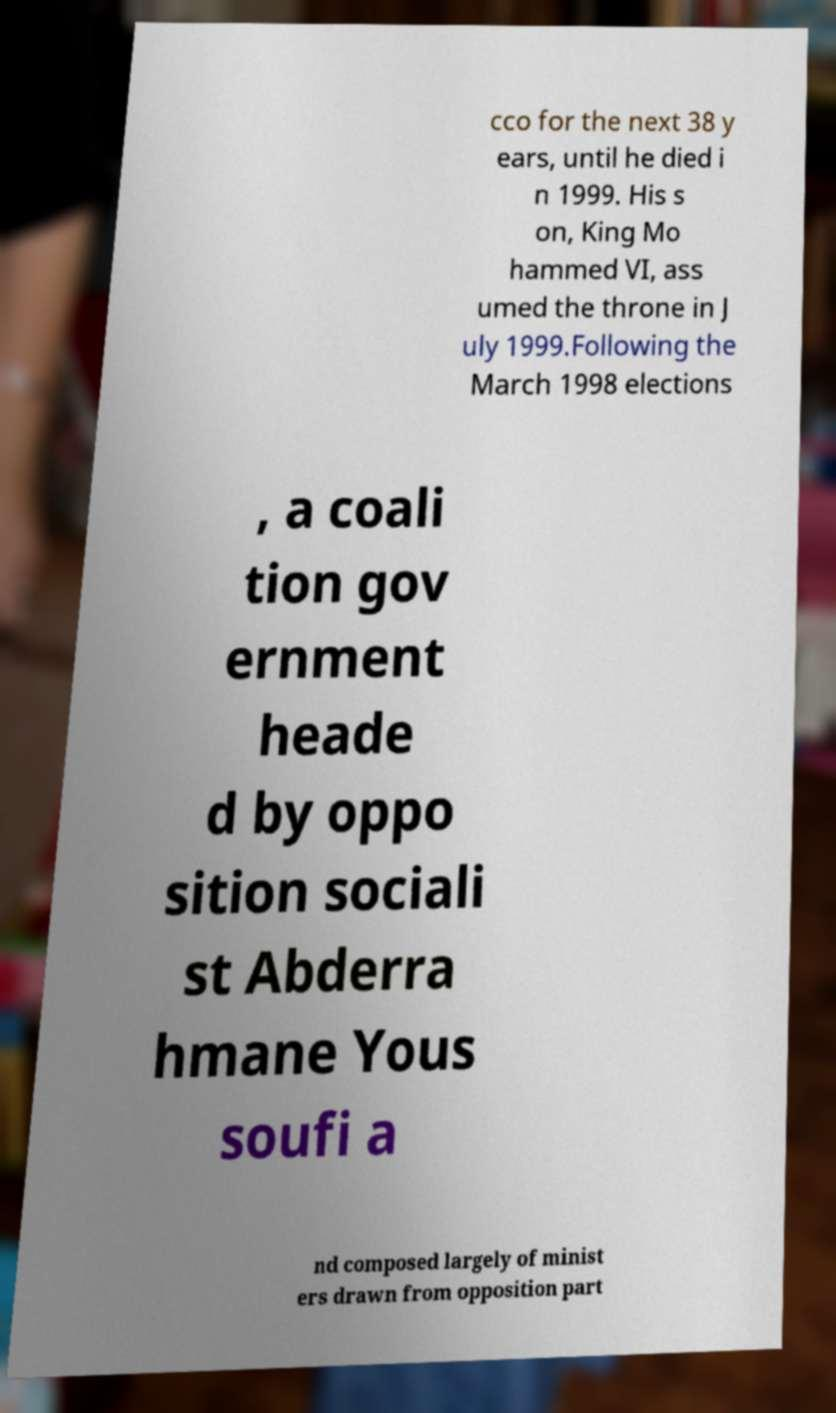What messages or text are displayed in this image? I need them in a readable, typed format. cco for the next 38 y ears, until he died i n 1999. His s on, King Mo hammed VI, ass umed the throne in J uly 1999.Following the March 1998 elections , a coali tion gov ernment heade d by oppo sition sociali st Abderra hmane Yous soufi a nd composed largely of minist ers drawn from opposition part 